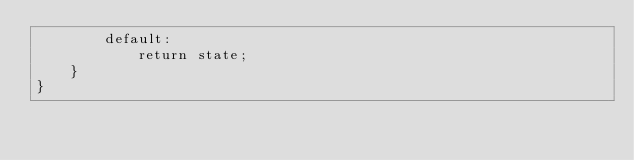<code> <loc_0><loc_0><loc_500><loc_500><_JavaScript_>        default:
            return state;
    }
}</code> 